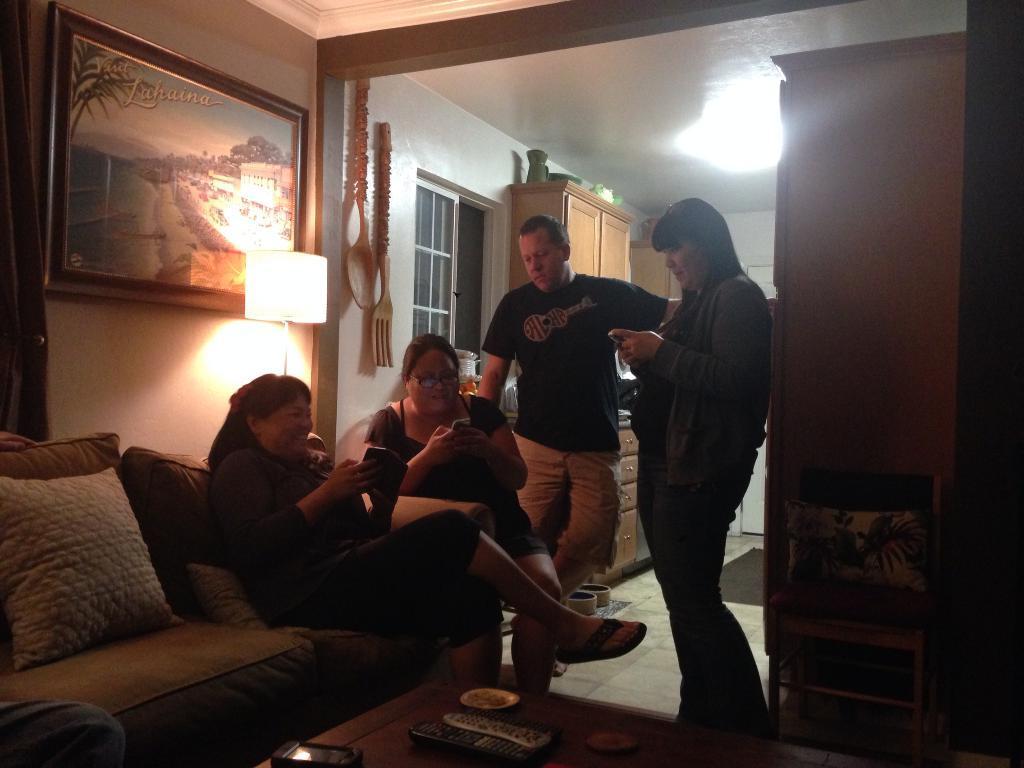Please provide a concise description of this image. In this image we can see this people sitting on the sofa and this people are standing. In the background we can see photo frame, lamp, glass windows and cupboards. 